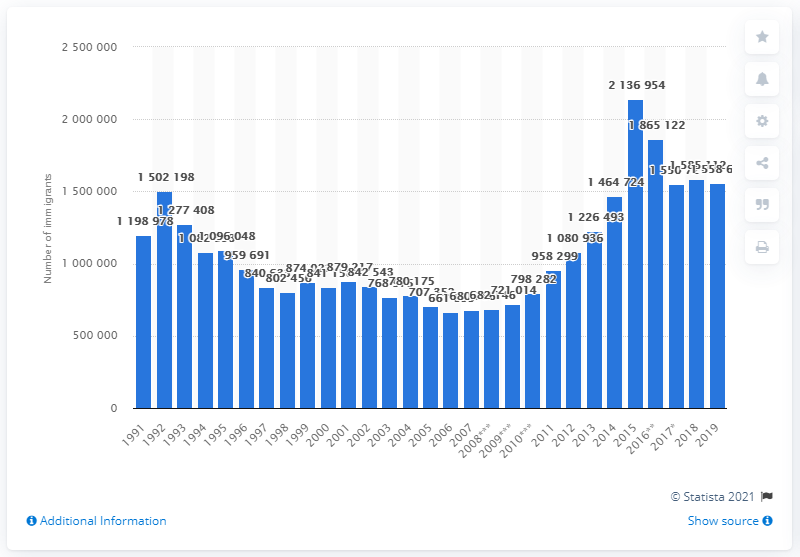Mention a couple of crucial points in this snapshot. In 2019, the number of immigrants in Germany was 1558612. 